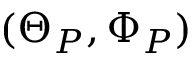Convert formula to latex. <formula><loc_0><loc_0><loc_500><loc_500>( \Theta _ { P } , \Phi _ { P } )</formula> 